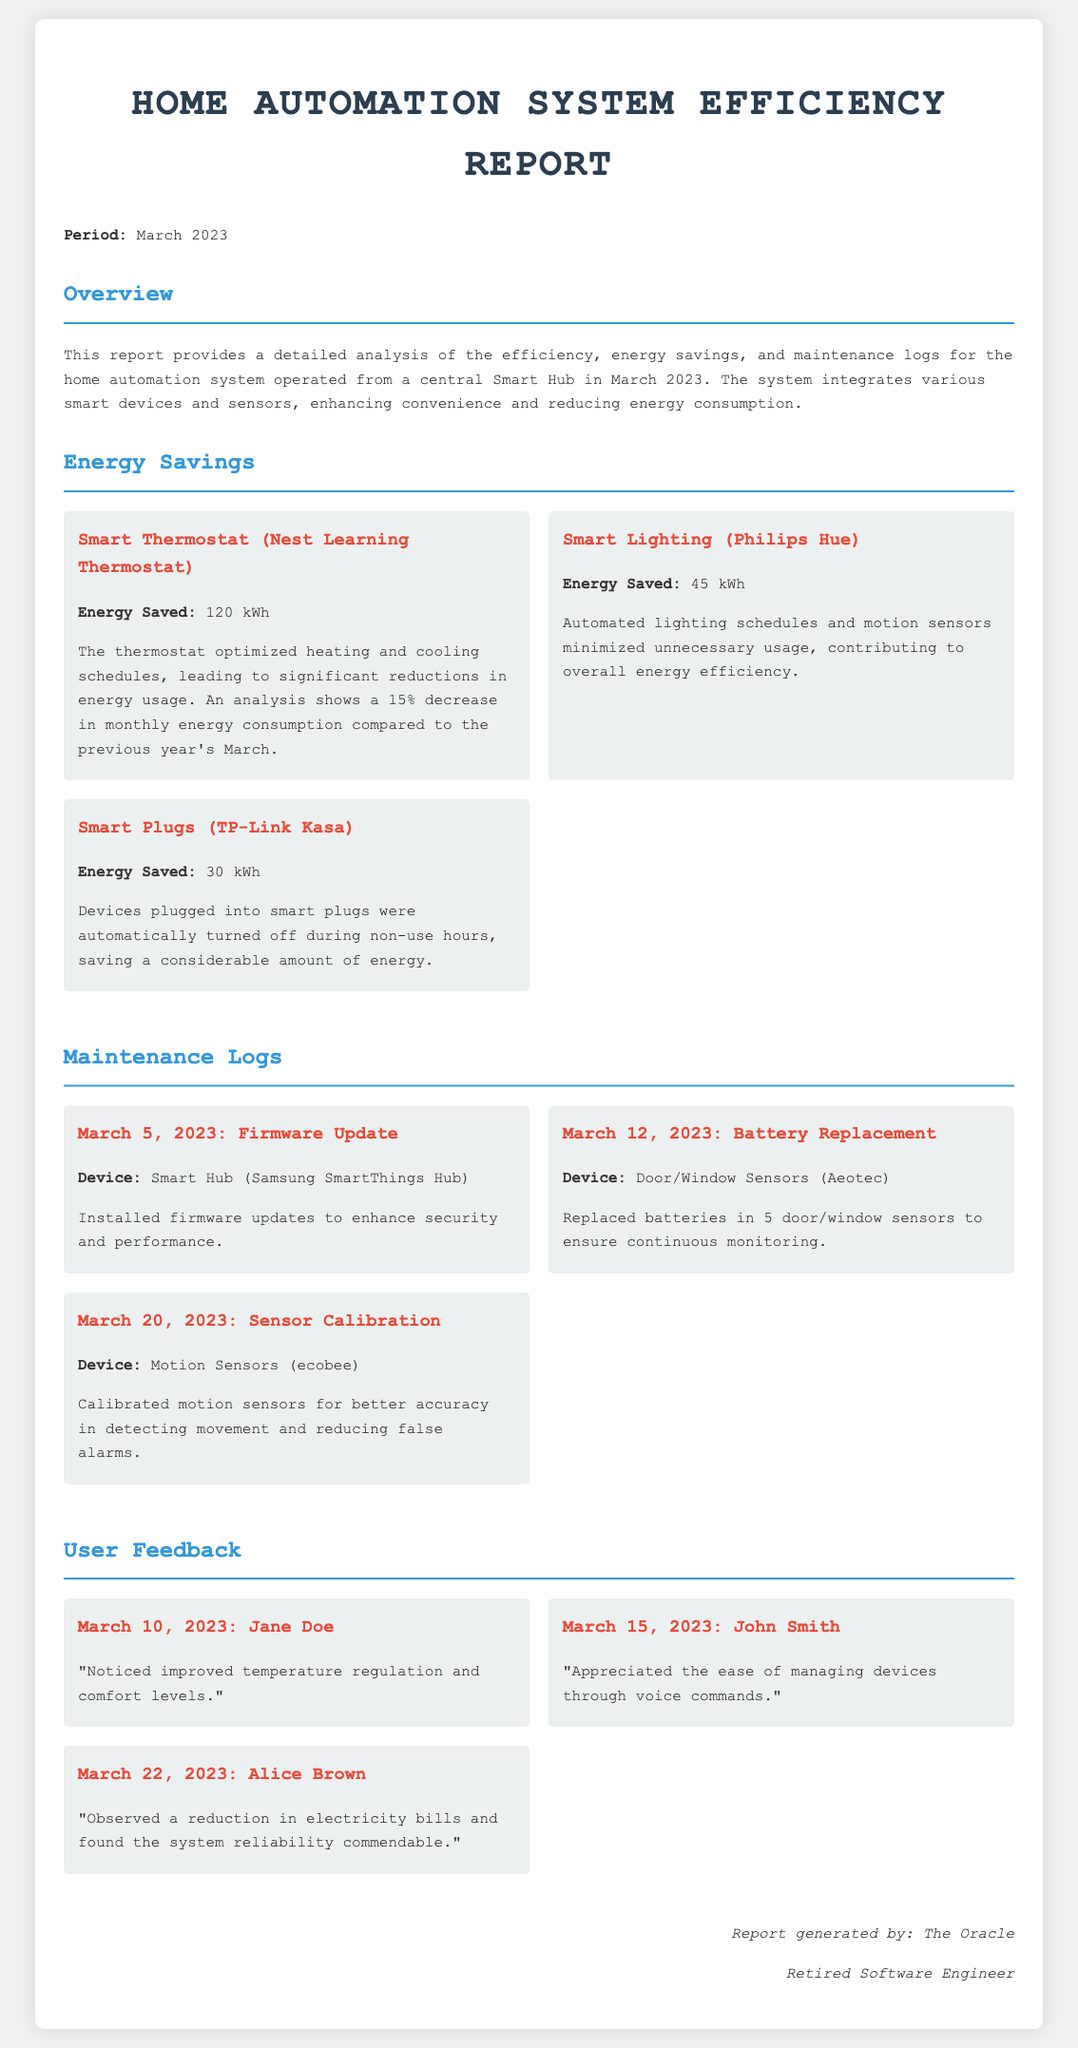What was the total energy saved by the Smart Thermostat? The Smart Thermostat saved 120 kWh as noted in the energy savings section of the document.
Answer: 120 kWh What date was the battery replacement performed? The maintenance log indicates the battery replacement was done on March 12, 2023.
Answer: March 12, 2023 Who provided feedback on March 15, 2023? The user feedback section mentions John Smith as providing feedback on that date.
Answer: John Smith How many kWh were saved by the Smart Lighting? The Smart Lighting saved 45 kWh, which is stated in the energy savings section.
Answer: 45 kWh What device had a firmware update on March 5, 2023? The firmware update was performed on the Smart Hub (Samsung SmartThings Hub), as detailed in the maintenance logs.
Answer: Smart Hub (Samsung SmartThings Hub) What percentage decrease in consumption did the Smart Thermostat achieve compared to last year's March? The report notes a 15% decrease in monthly energy consumption compared to the previous year's March.
Answer: 15% How many door/window sensors had batteries replaced? The log states that batteries were replaced in 5 door/window sensors on March 12, 2023.
Answer: 5 What was the main benefit noted by Alice Brown in her feedback? Alice Brown observed a reduction in electricity bills and found the system reliability commendable.
Answer: Reduction in electricity bills What type of document is this? This document is identified as a "Home Automation System Efficiency Report" at the beginning.
Answer: Home Automation System Efficiency Report 